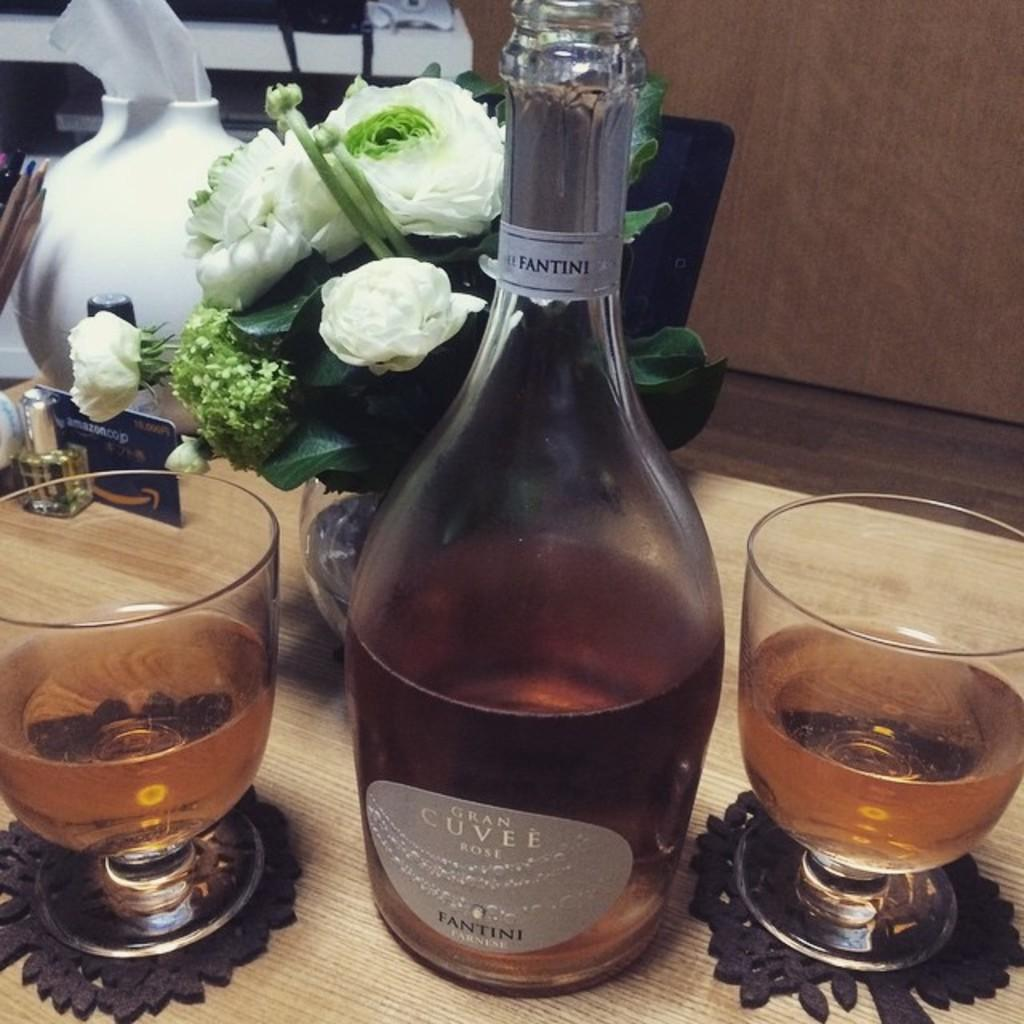What type of furniture is present in the image? There is a chair and a table in the image. What objects can be seen on the table? There is a bottle and a wine glass on the table in the image. What is located near the table? There is a flower pot in the image. What type of pocket can be seen on the chair in the image? There is no pocket present on the chair in the image. Does the existence of the flower pot in the image prove the existence of aliens? The presence of a flower pot in the image does not prove the existence of aliens, as it is a common household item. 